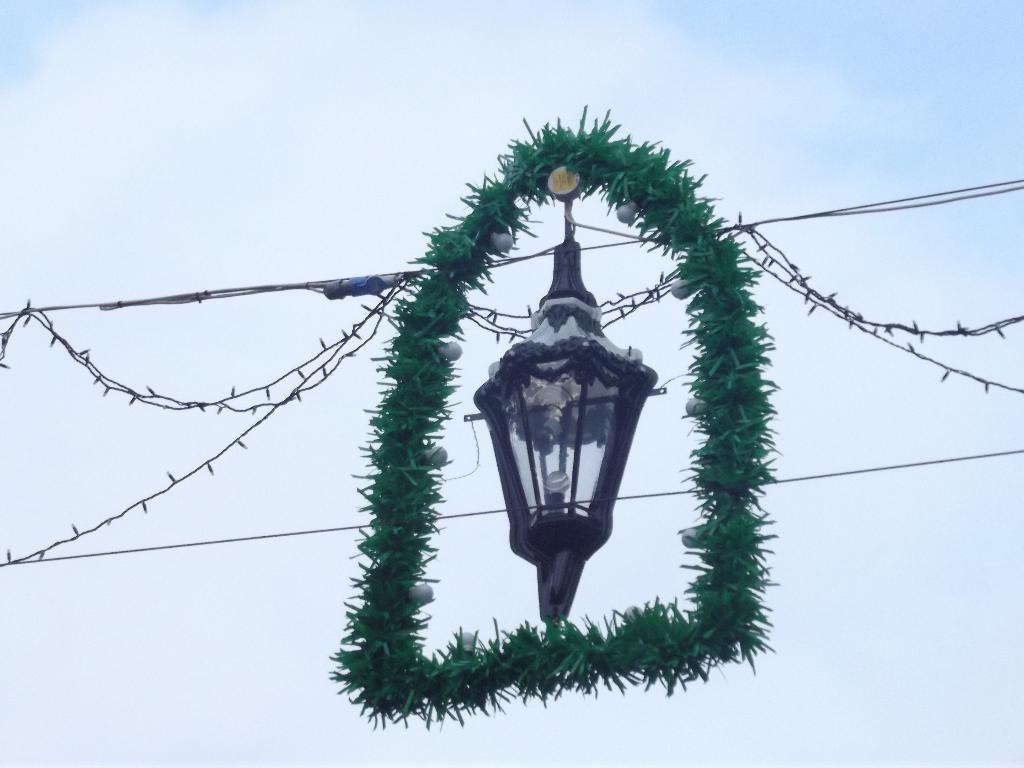How would you summarize this image in a sentence or two? In this image we can see a lamp with a ribbon, some wires and ceiling lights. On the backside we can see the sky which looks cloudy. 